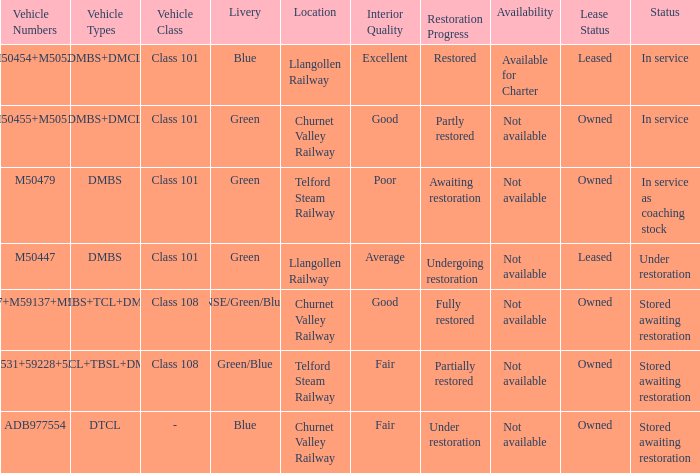What status is the vehicle numbers of adb977554? Stored awaiting restoration. 